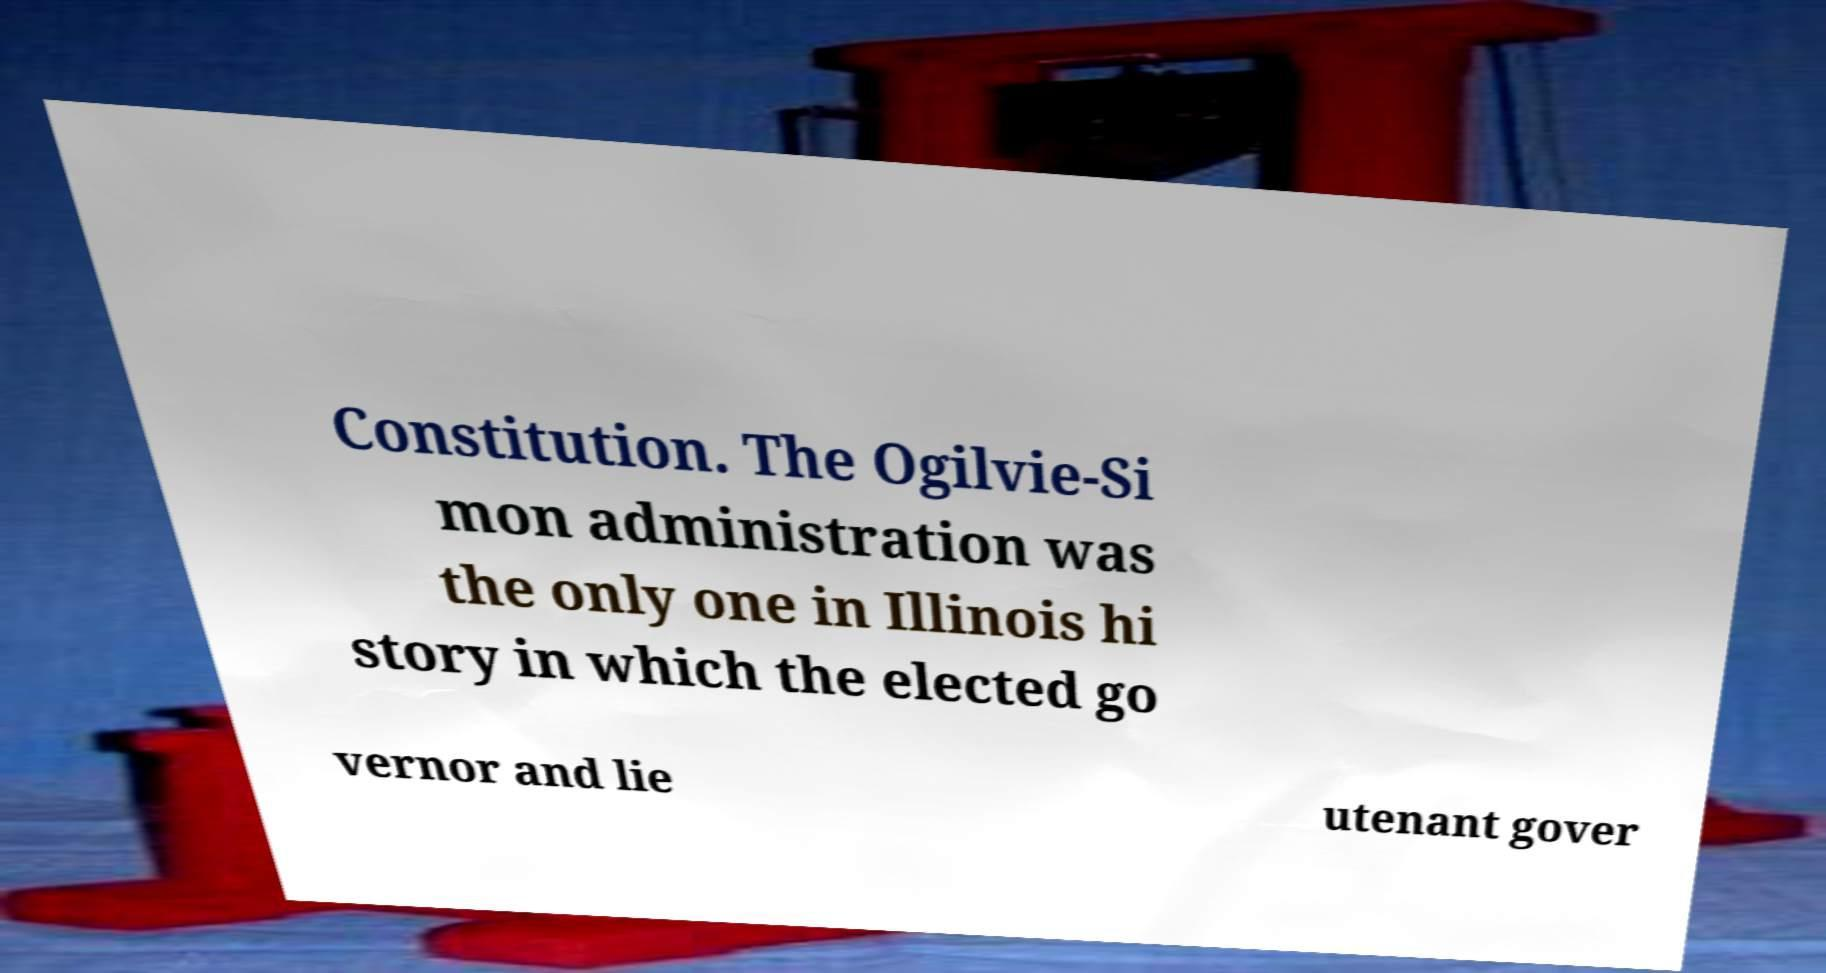Please read and relay the text visible in this image. What does it say? Constitution. The Ogilvie-Si mon administration was the only one in Illinois hi story in which the elected go vernor and lie utenant gover 